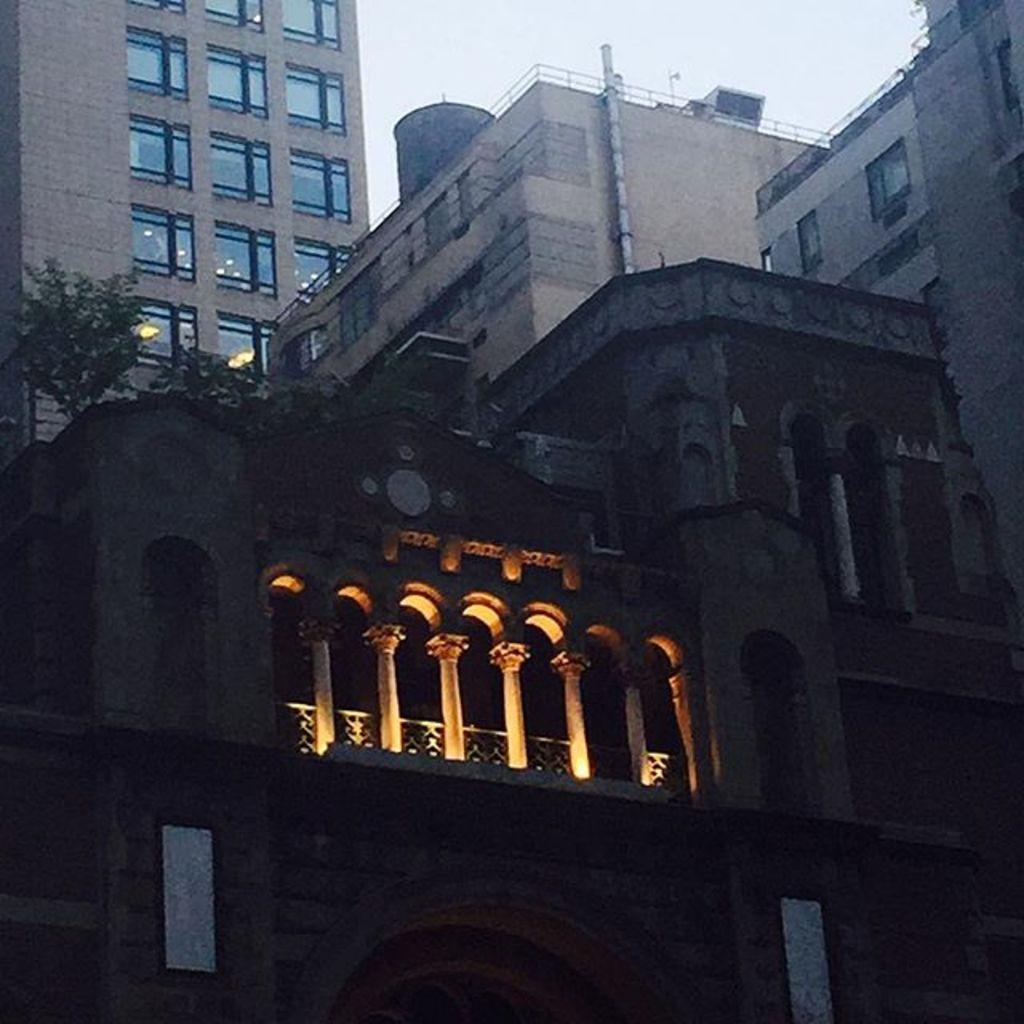What type of structures are visible in the image? There are buildings with windows in the image. What other elements can be seen in the image besides the buildings? There are plants, lights, a railing, and a pipe visible in the image. What can be seen in the background of the image? The sky is visible in the background of the image. What channel is the test being shown on in the image? There is no television or channel present in the image; it features buildings, plants, lights, a railing, and a pipe. 